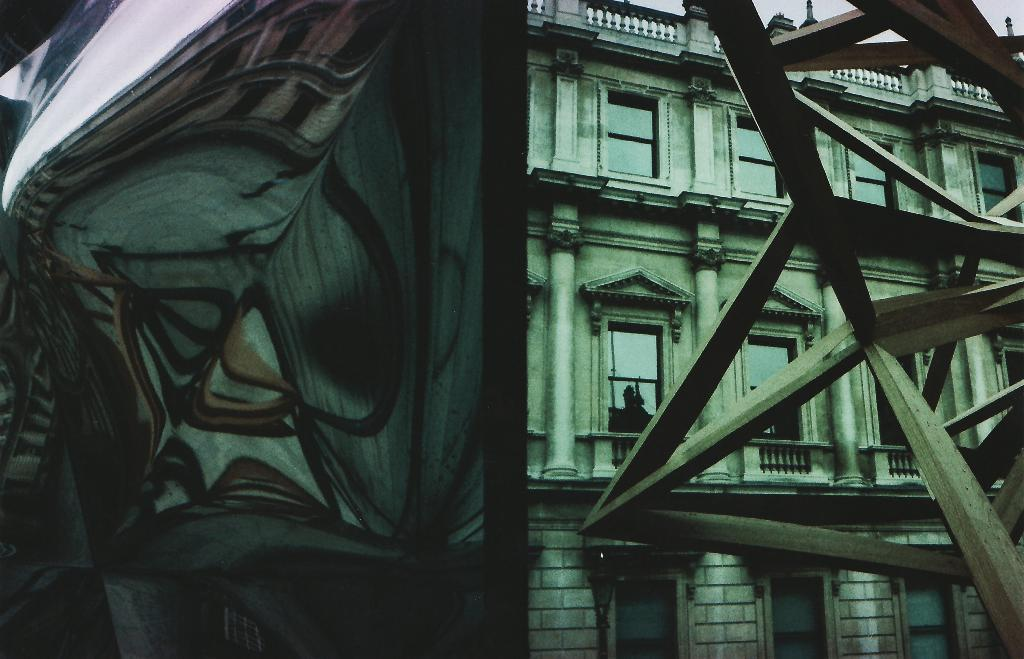What type of structure is visible in the image? There is a building in the image. What feature can be seen on the building? The building has windows. What object is located in front of the building? There is a pole in front of the building. Can you see any donkeys near the coast in the image? There is no coast or donkey present in the image. 